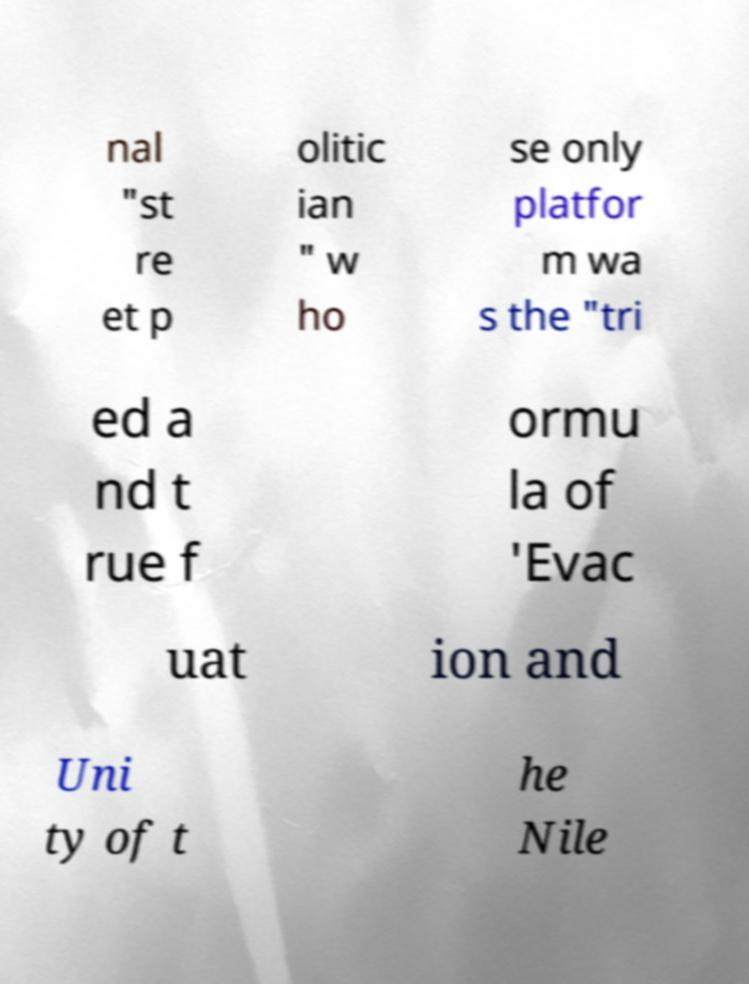What messages or text are displayed in this image? I need them in a readable, typed format. nal "st re et p olitic ian " w ho se only platfor m wa s the "tri ed a nd t rue f ormu la of 'Evac uat ion and Uni ty of t he Nile 